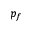Convert formula to latex. <formula><loc_0><loc_0><loc_500><loc_500>p _ { f }</formula> 